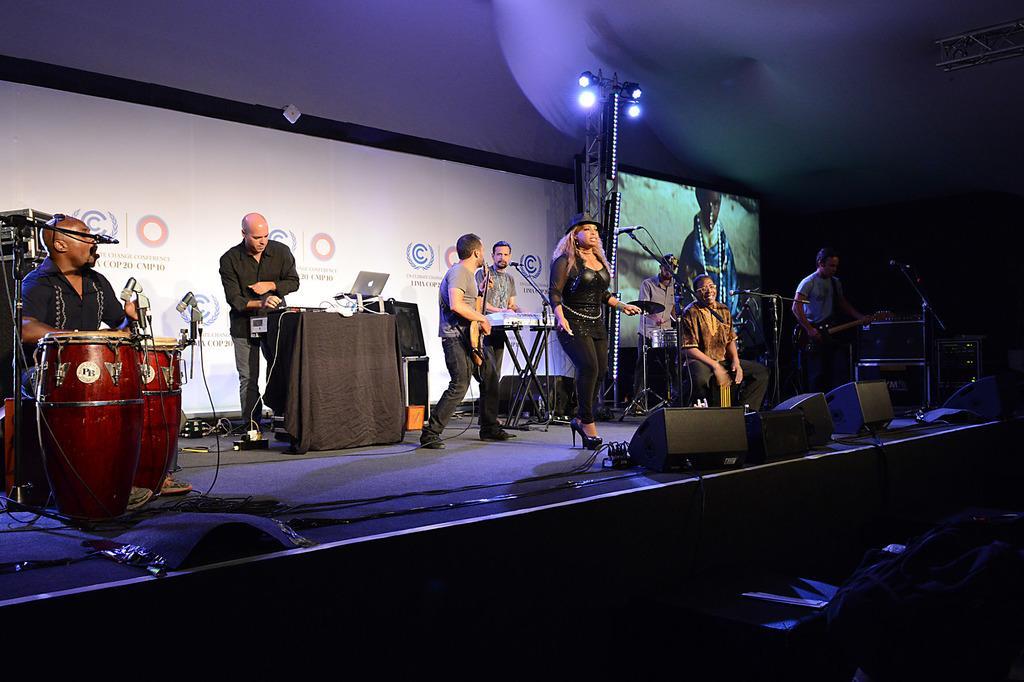Describe this image in one or two sentences. So many people on the stage. one woman is singing and other people are playing guitars, keyboard and drums. one person is standing and one table is there and one laptop, behind the people one screen is there, there are the speakers and spotlights also their, backside of the people their is a big cloth some text written on it and lights also there. Woman is wearing a hat. 